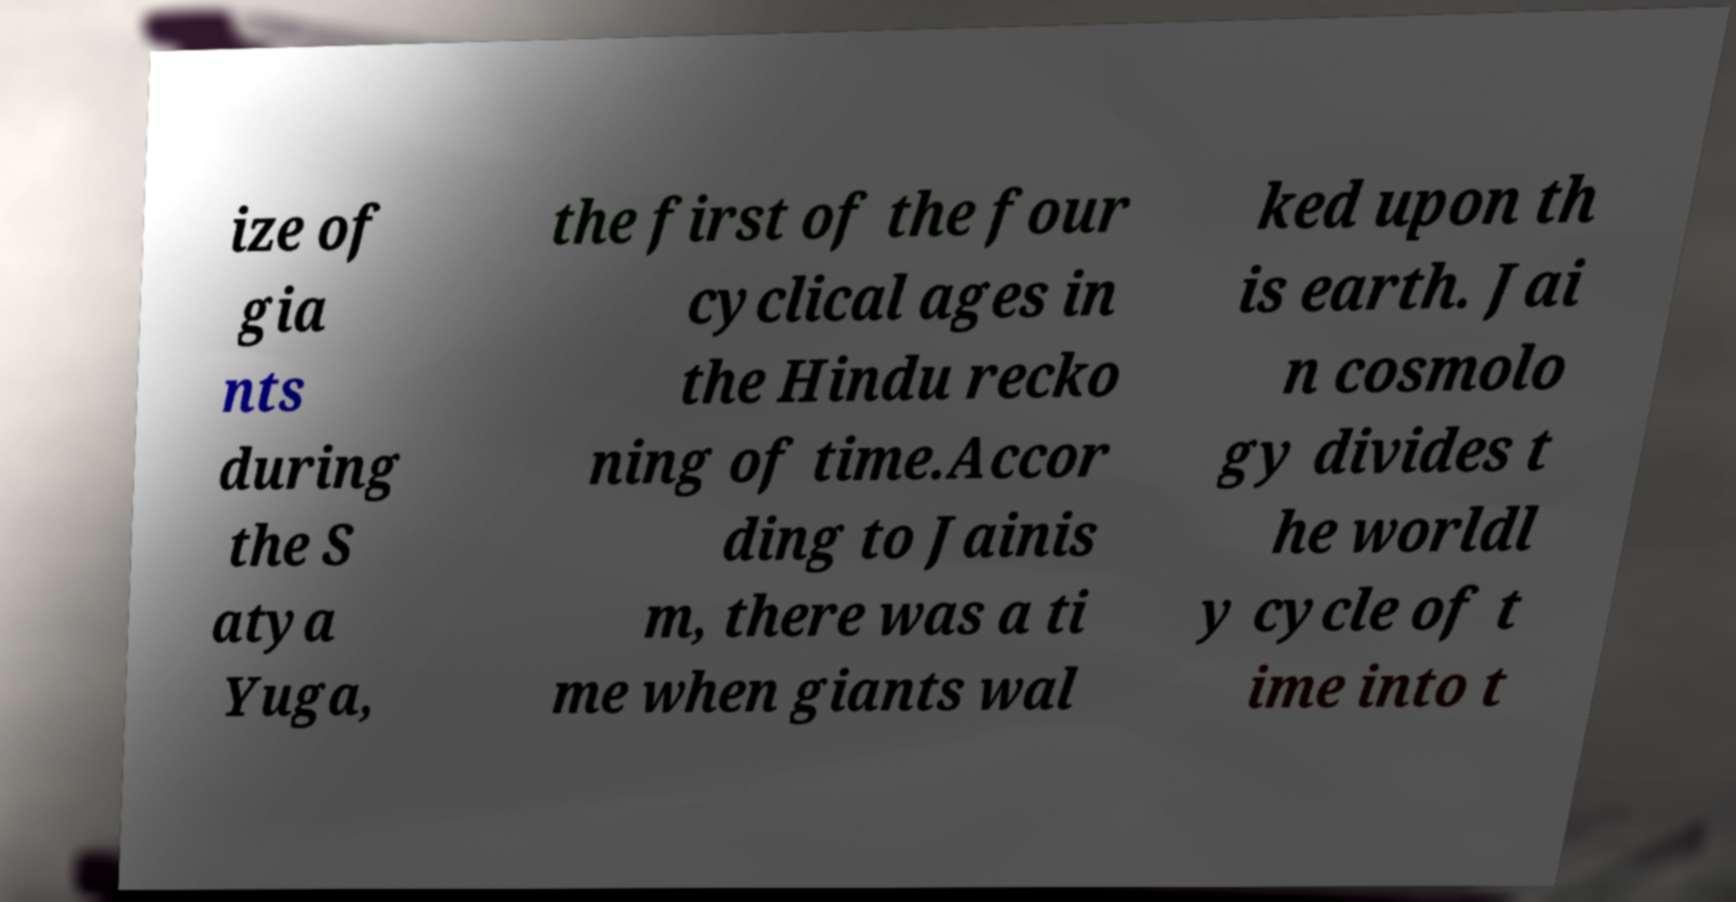Please read and relay the text visible in this image. What does it say? ize of gia nts during the S atya Yuga, the first of the four cyclical ages in the Hindu recko ning of time.Accor ding to Jainis m, there was a ti me when giants wal ked upon th is earth. Jai n cosmolo gy divides t he worldl y cycle of t ime into t 